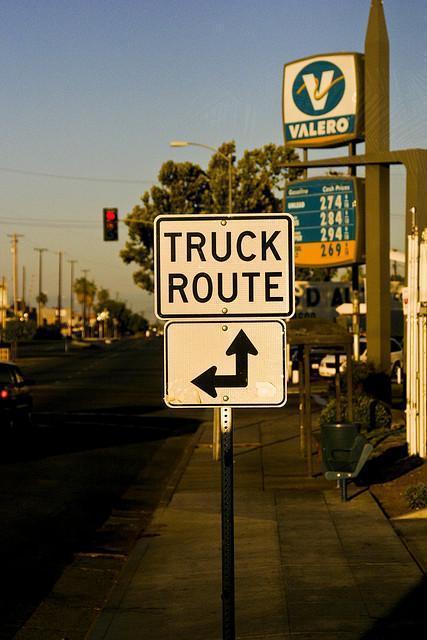How many people in the photo?
Give a very brief answer. 0. 